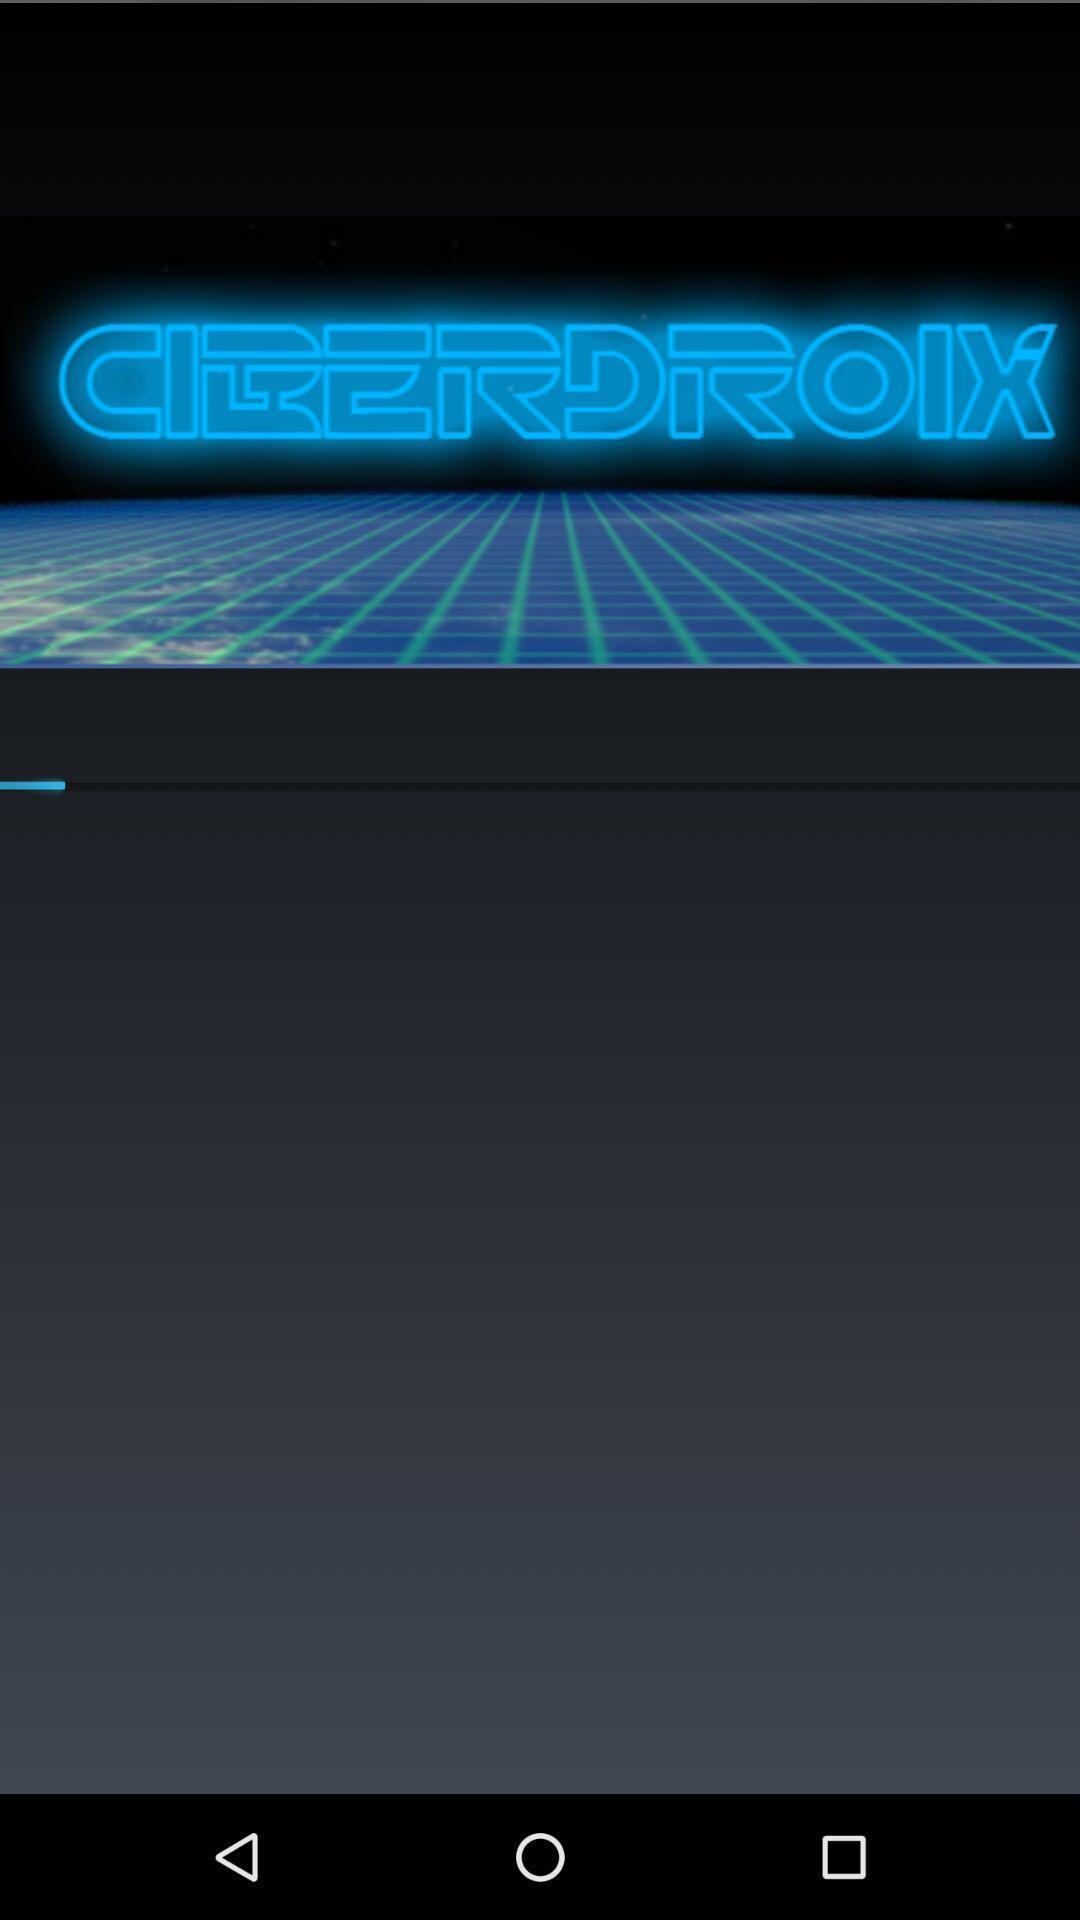Summarize the main components in this picture. Screen displaying the welcome page. 